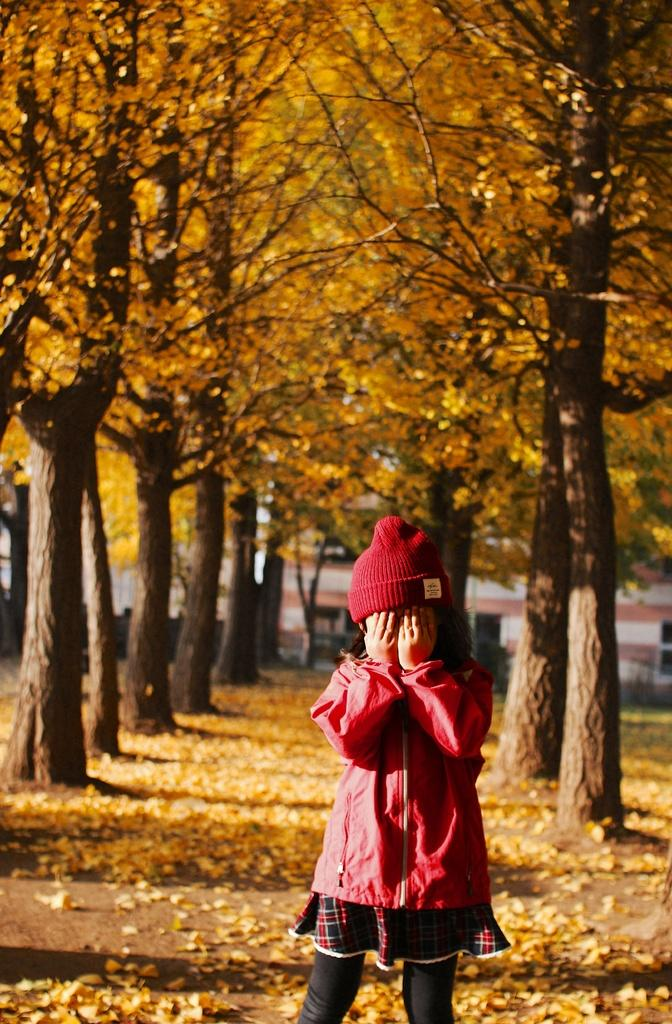What is the main subject of the image? There is a girl standing in the image. What can be seen behind the girl? There are trees visible behind the girl. What is present on the ground in the image? Leaves are present on the ground. What type of structure is visible in the background of the image? There is a building in the background of the image. What type of rhythm can be heard coming from the girl in the image? There is no indication of sound or rhythm in the image, as it is a still photograph. 